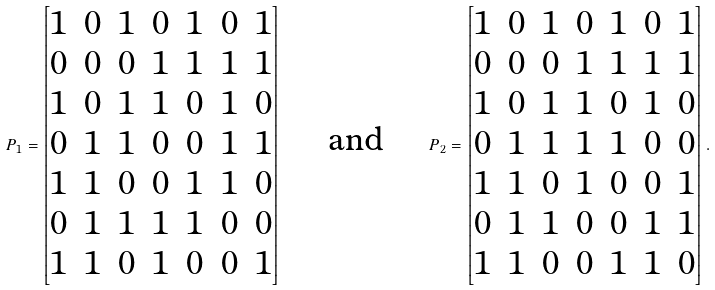Convert formula to latex. <formula><loc_0><loc_0><loc_500><loc_500>P _ { 1 } = \begin{bmatrix} 1 & 0 & 1 & 0 & 1 & 0 & 1 \\ 0 & 0 & 0 & 1 & 1 & 1 & 1 \\ 1 & 0 & 1 & 1 & 0 & 1 & 0 \\ 0 & 1 & 1 & 0 & 0 & 1 & 1 \\ 1 & 1 & 0 & 0 & 1 & 1 & 0 \\ 0 & 1 & 1 & 1 & 1 & 0 & 0 \\ 1 & 1 & 0 & 1 & 0 & 0 & 1 \end{bmatrix} \quad \text { and } \quad P _ { 2 } = \begin{bmatrix} 1 & 0 & 1 & 0 & 1 & 0 & 1 \\ 0 & 0 & 0 & 1 & 1 & 1 & 1 \\ 1 & 0 & 1 & 1 & 0 & 1 & 0 \\ 0 & 1 & 1 & 1 & 1 & 0 & 0 \\ 1 & 1 & 0 & 1 & 0 & 0 & 1 \\ 0 & 1 & 1 & 0 & 0 & 1 & 1 \\ 1 & 1 & 0 & 0 & 1 & 1 & 0 \end{bmatrix} .</formula> 